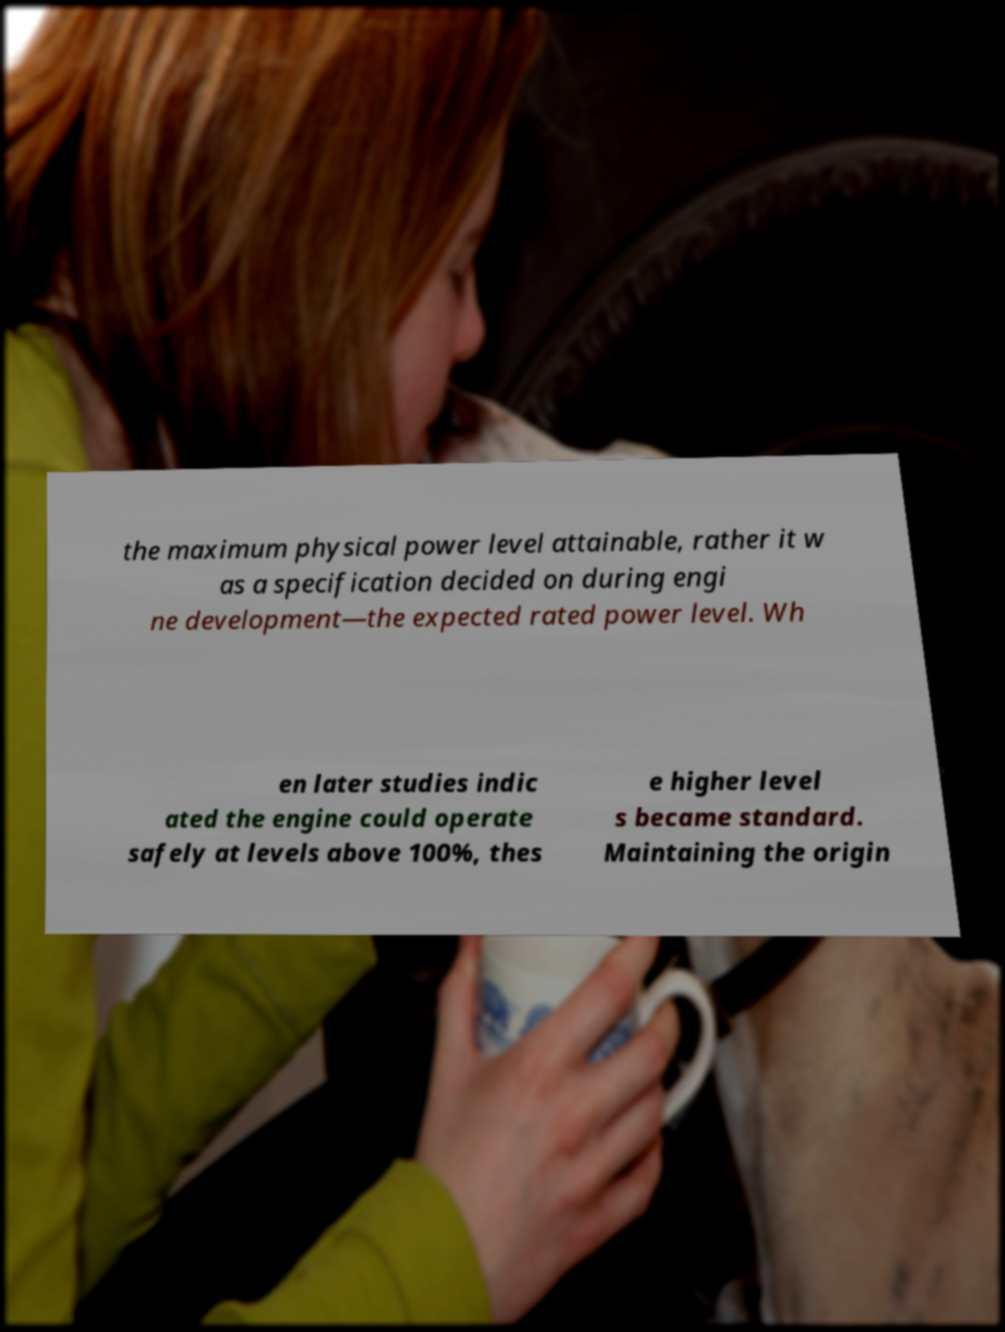Can you accurately transcribe the text from the provided image for me? the maximum physical power level attainable, rather it w as a specification decided on during engi ne development—the expected rated power level. Wh en later studies indic ated the engine could operate safely at levels above 100%, thes e higher level s became standard. Maintaining the origin 